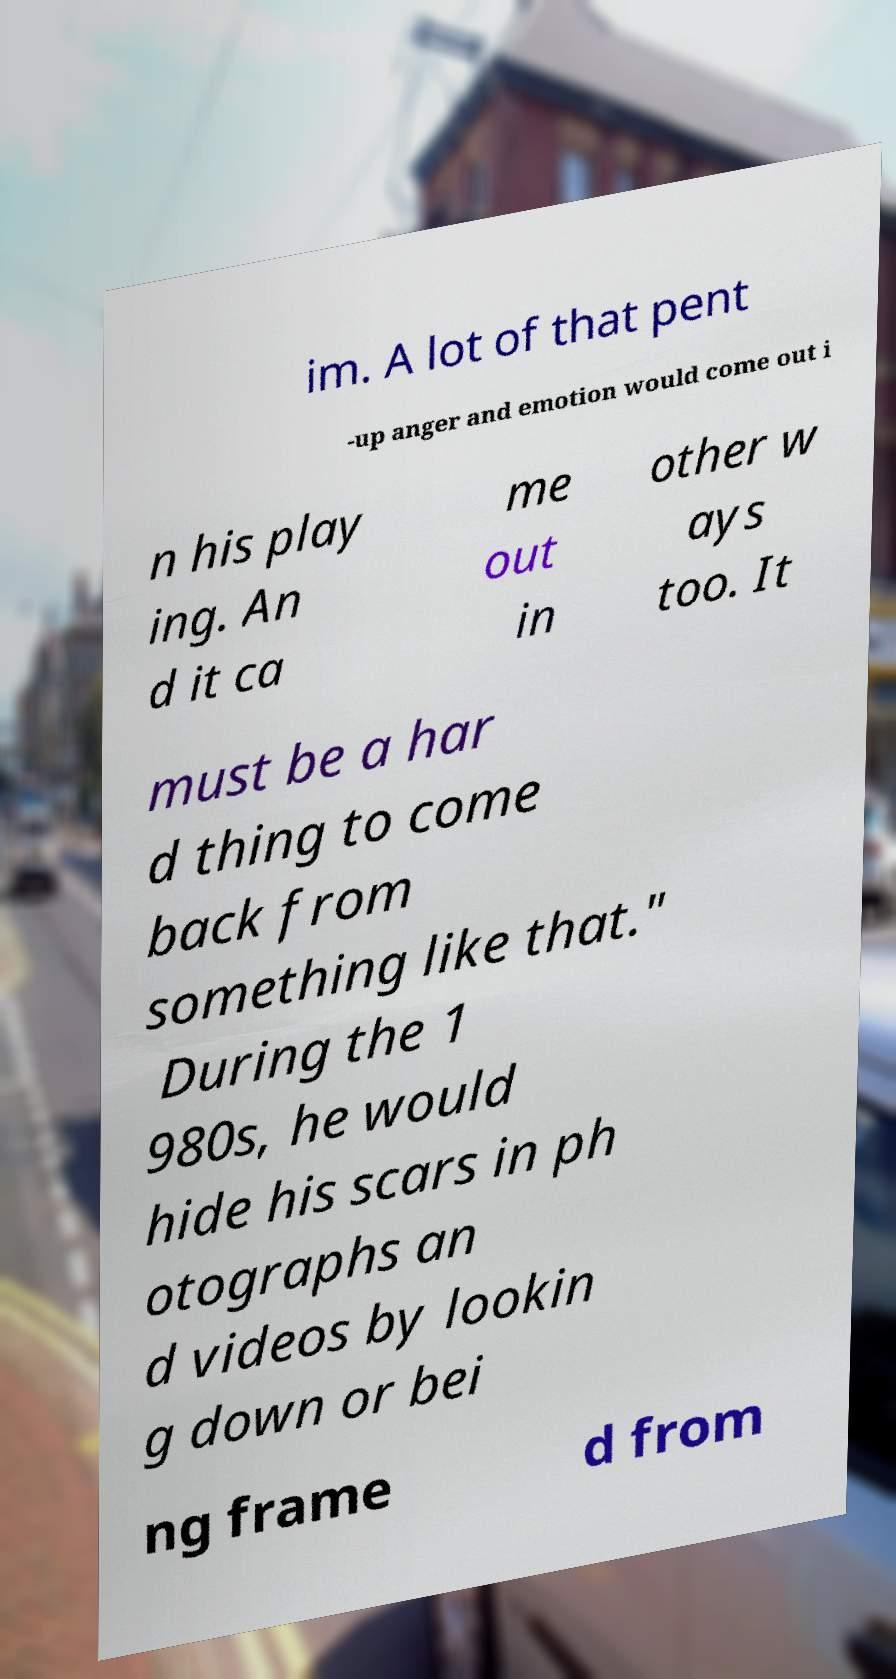Could you extract and type out the text from this image? im. A lot of that pent -up anger and emotion would come out i n his play ing. An d it ca me out in other w ays too. It must be a har d thing to come back from something like that." During the 1 980s, he would hide his scars in ph otographs an d videos by lookin g down or bei ng frame d from 